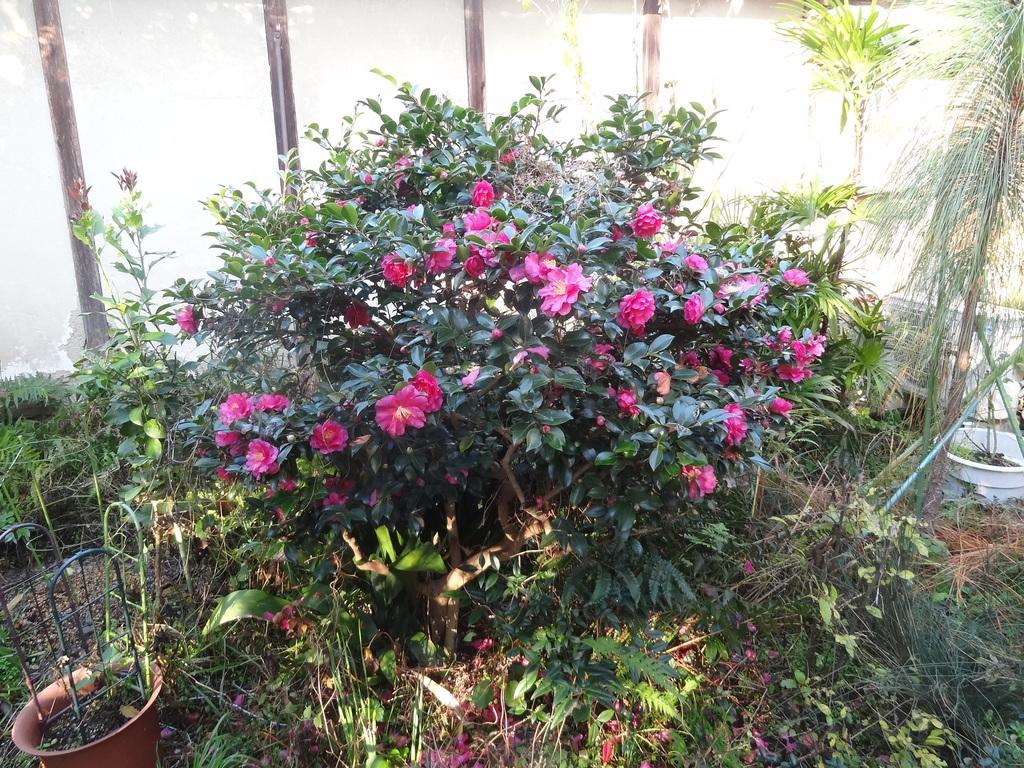What is the main subject in the center of the image? There is a plant with flowers in the center of the image. What can be seen to the left side of the image? There is a container with metal frames to the left side of the image. What is visible in the background of the image? There is a group of plants and a wall visible in the background of the image. How many mint leaves can be seen in the can that is dropped on the ground in the image? There is no can or mint leaves present in the image. 